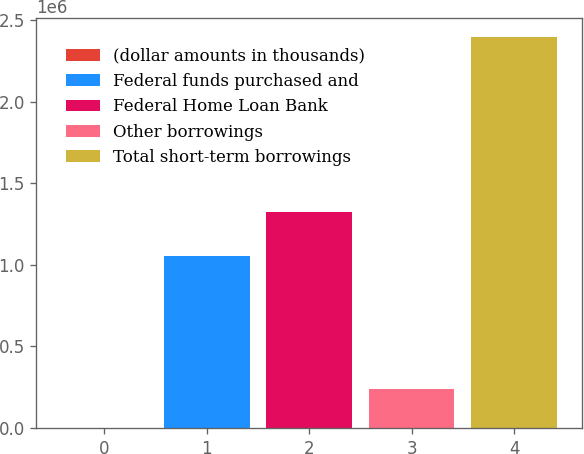<chart> <loc_0><loc_0><loc_500><loc_500><bar_chart><fcel>(dollar amounts in thousands)<fcel>Federal funds purchased and<fcel>Federal Home Loan Bank<fcel>Other borrowings<fcel>Total short-term borrowings<nl><fcel>2014<fcel>1.0581e+06<fcel>1.325e+06<fcel>241523<fcel>2.3971e+06<nl></chart> 